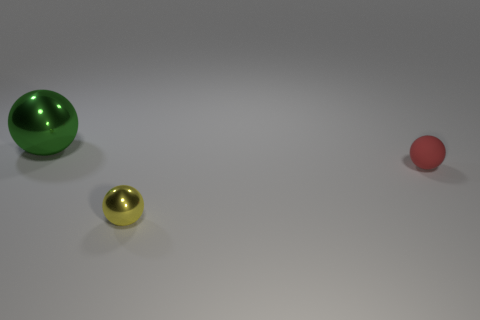What number of small yellow objects are the same shape as the red rubber thing?
Your response must be concise. 1. There is a red sphere that is the same size as the yellow metal ball; what material is it?
Provide a short and direct response. Rubber. Are there any tiny red spheres that have the same material as the green thing?
Provide a short and direct response. No. What is the color of the ball that is behind the yellow thing and left of the matte thing?
Keep it short and to the point. Green. How many other objects are the same color as the rubber sphere?
Offer a terse response. 0. There is a tiny object that is right of the metallic ball in front of the object that is on the left side of the yellow sphere; what is it made of?
Your answer should be compact. Rubber. How many cylinders are either big cyan things or tiny yellow objects?
Ensure brevity in your answer.  0. Is there any other thing that has the same size as the red sphere?
Keep it short and to the point. Yes. What number of green metallic spheres are to the right of the large sphere that is behind the shiny sphere in front of the big green object?
Give a very brief answer. 0. Do the large green shiny object and the yellow thing have the same shape?
Provide a short and direct response. Yes. 